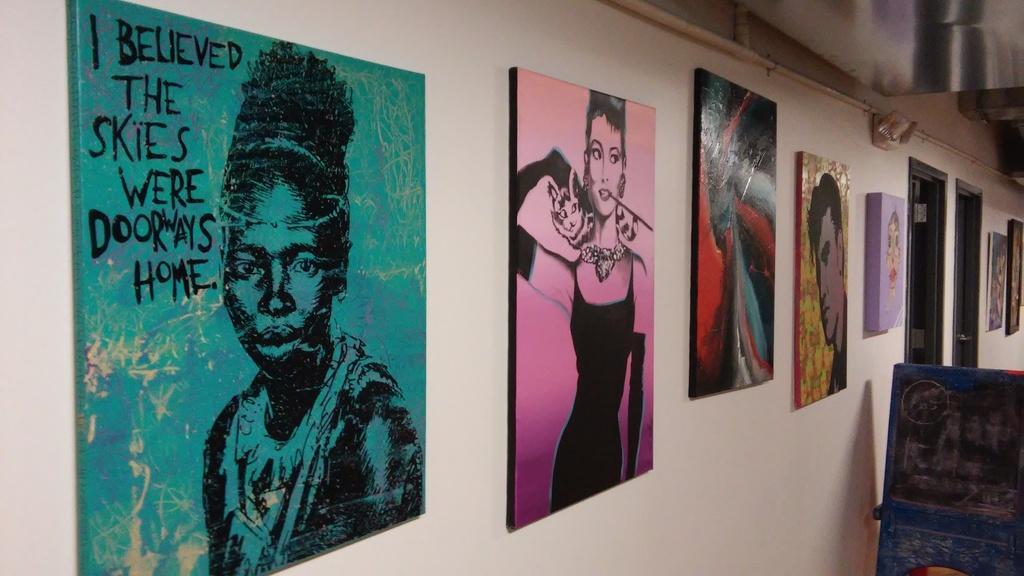How would you summarize this image in a sentence or two? In this picture there are boards on the wall. On the boards, there is text and there are paintings of people. At the bottom right there is an object. At the top there is a pipe on the wall. 